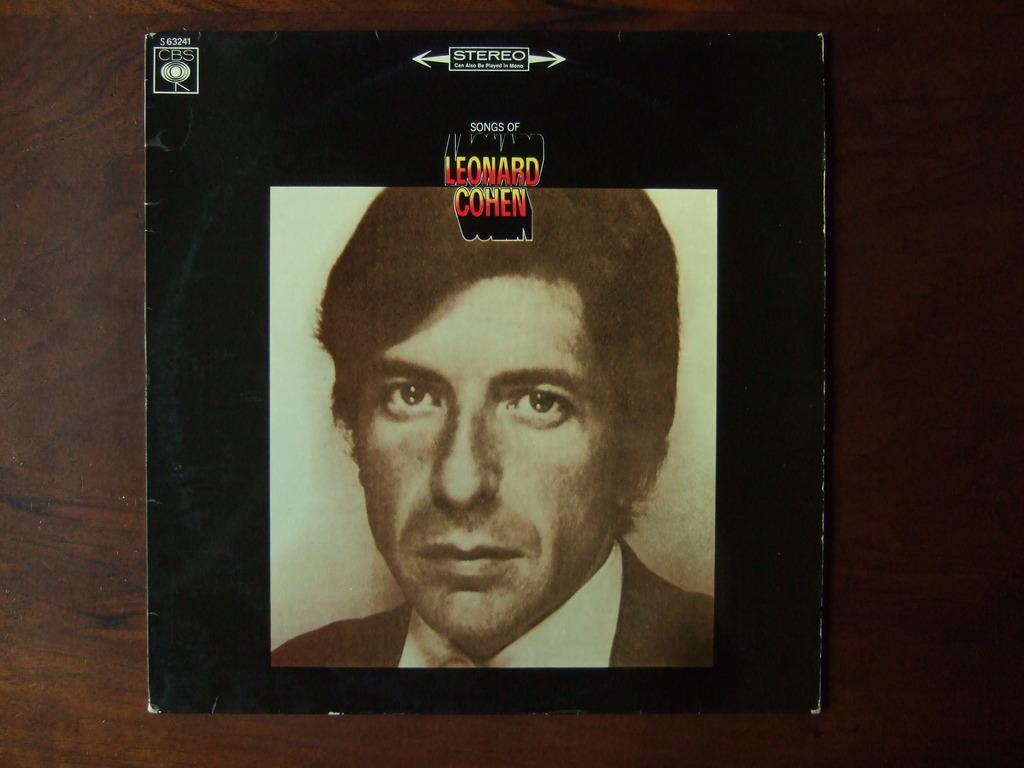What is the main subject of the image? There is a photo of a man in the image. Where is the photo located? The photo is placed on a table. What type of quill is the man holding in the photo? There is no quill present in the photo; the man is not holding anything. 